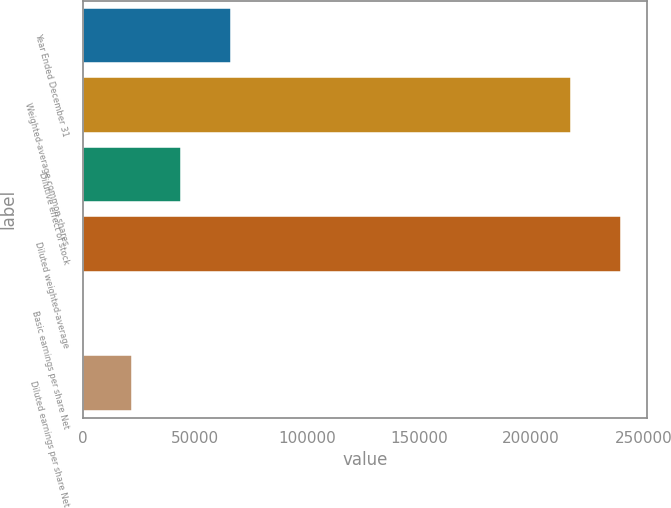Convert chart. <chart><loc_0><loc_0><loc_500><loc_500><bar_chart><fcel>Year Ended December 31<fcel>Weighted-average common shares<fcel>Dilutive effect of stock<fcel>Diluted weighted-average<fcel>Basic earnings per share Net<fcel>Diluted earnings per share Net<nl><fcel>65837.1<fcel>217930<fcel>43891.5<fcel>239876<fcel>0.08<fcel>21945.8<nl></chart> 